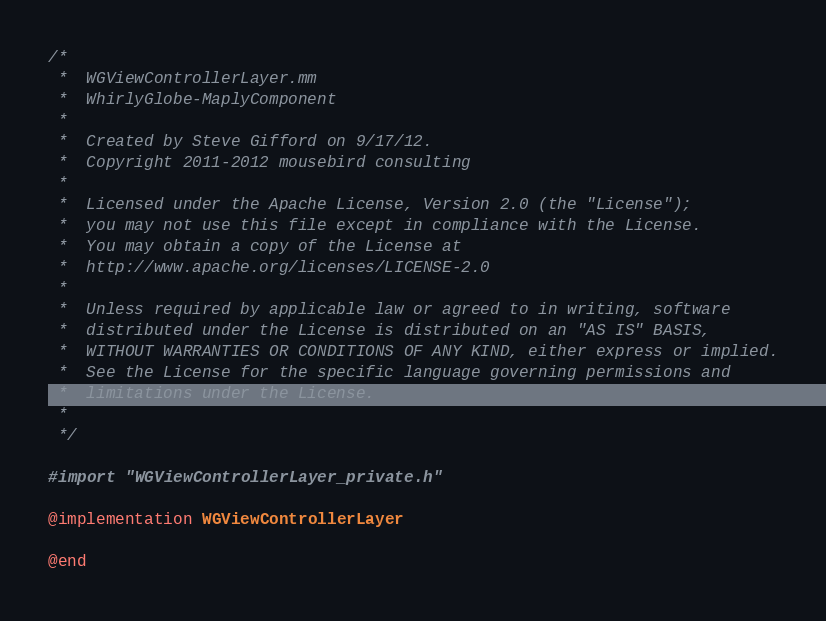<code> <loc_0><loc_0><loc_500><loc_500><_ObjectiveC_>/*
 *  WGViewControllerLayer.mm
 *  WhirlyGlobe-MaplyComponent
 *
 *  Created by Steve Gifford on 9/17/12.
 *  Copyright 2011-2012 mousebird consulting
 *
 *  Licensed under the Apache License, Version 2.0 (the "License");
 *  you may not use this file except in compliance with the License.
 *  You may obtain a copy of the License at
 *  http://www.apache.org/licenses/LICENSE-2.0
 *
 *  Unless required by applicable law or agreed to in writing, software
 *  distributed under the License is distributed on an "AS IS" BASIS,
 *  WITHOUT WARRANTIES OR CONDITIONS OF ANY KIND, either express or implied.
 *  See the License for the specific language governing permissions and
 *  limitations under the License.
 *
 */

#import "WGViewControllerLayer_private.h"

@implementation WGViewControllerLayer

@end</code> 